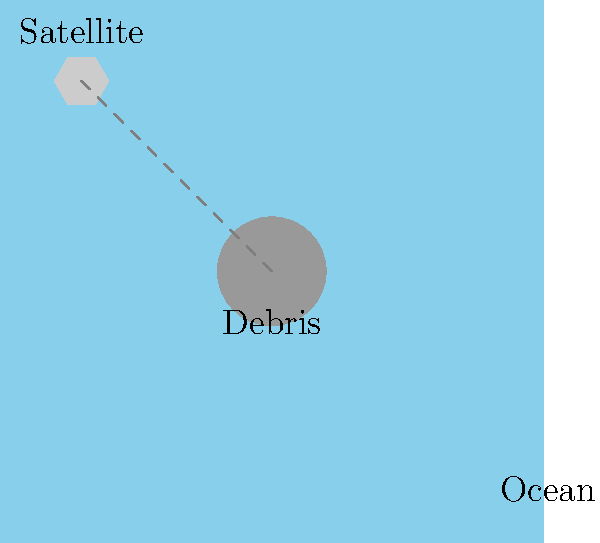In satellite imagery analysis for identifying aircraft debris, what key factor would you consider when distinguishing potential MH370 debris from other objects in the Indian Ocean? To identify potential MH370 debris from satellite imagery, consider the following factors:

1. Size: Aircraft debris would typically be larger than most natural ocean debris.
2. Shape: Look for geometric shapes or recognizable aircraft parts.
3. Reflectivity: Aircraft materials often have different reflective properties than natural objects.
4. Distribution: Multiple pieces of debris may be clustered together.
5. Location: Consider the last known position of MH370 and possible drift patterns.
6. Contrast: Debris may appear as a different color or shade compared to the surrounding water.
7. Temporal analysis: Compare images over time to identify persistent objects.
8. Resolution: Higher resolution images allow for better identification of small details.

The key factor among these is shape. Unusual geometric shapes or recognizable aircraft parts are strong indicators of potential aircraft debris, as they are less likely to occur naturally in the ocean environment.
Answer: Shape of the object 